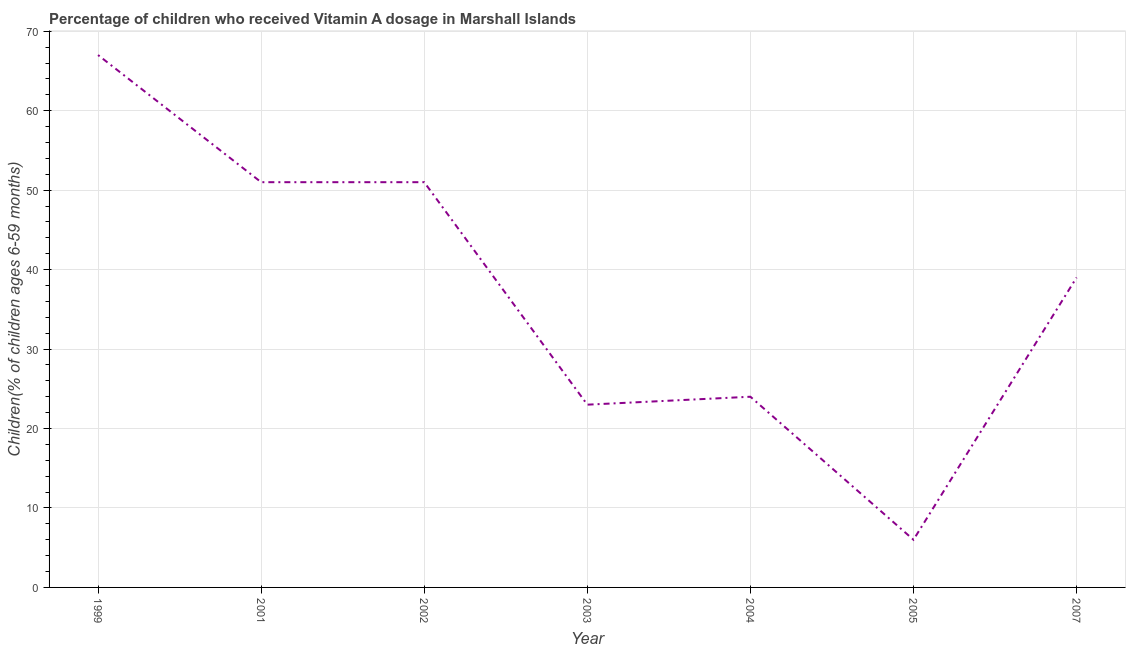What is the vitamin a supplementation coverage rate in 2005?
Give a very brief answer. 6. Across all years, what is the maximum vitamin a supplementation coverage rate?
Offer a terse response. 67. Across all years, what is the minimum vitamin a supplementation coverage rate?
Offer a terse response. 6. What is the sum of the vitamin a supplementation coverage rate?
Your response must be concise. 261. What is the difference between the vitamin a supplementation coverage rate in 1999 and 2002?
Offer a terse response. 16. What is the average vitamin a supplementation coverage rate per year?
Your answer should be compact. 37.29. What is the ratio of the vitamin a supplementation coverage rate in 2005 to that in 2007?
Your answer should be very brief. 0.15. What is the difference between the highest and the second highest vitamin a supplementation coverage rate?
Make the answer very short. 16. What is the difference between the highest and the lowest vitamin a supplementation coverage rate?
Your answer should be compact. 61. Does the vitamin a supplementation coverage rate monotonically increase over the years?
Your response must be concise. No. How many lines are there?
Give a very brief answer. 1. What is the difference between two consecutive major ticks on the Y-axis?
Ensure brevity in your answer.  10. Does the graph contain any zero values?
Your answer should be very brief. No. What is the title of the graph?
Offer a very short reply. Percentage of children who received Vitamin A dosage in Marshall Islands. What is the label or title of the Y-axis?
Your response must be concise. Children(% of children ages 6-59 months). What is the Children(% of children ages 6-59 months) in 1999?
Make the answer very short. 67. What is the Children(% of children ages 6-59 months) of 2004?
Make the answer very short. 24. What is the difference between the Children(% of children ages 6-59 months) in 1999 and 2002?
Make the answer very short. 16. What is the difference between the Children(% of children ages 6-59 months) in 1999 and 2007?
Make the answer very short. 28. What is the difference between the Children(% of children ages 6-59 months) in 2001 and 2003?
Keep it short and to the point. 28. What is the difference between the Children(% of children ages 6-59 months) in 2001 and 2007?
Keep it short and to the point. 12. What is the difference between the Children(% of children ages 6-59 months) in 2002 and 2004?
Provide a short and direct response. 27. What is the difference between the Children(% of children ages 6-59 months) in 2003 and 2004?
Your response must be concise. -1. What is the difference between the Children(% of children ages 6-59 months) in 2003 and 2005?
Your response must be concise. 17. What is the difference between the Children(% of children ages 6-59 months) in 2004 and 2005?
Offer a terse response. 18. What is the difference between the Children(% of children ages 6-59 months) in 2004 and 2007?
Keep it short and to the point. -15. What is the difference between the Children(% of children ages 6-59 months) in 2005 and 2007?
Ensure brevity in your answer.  -33. What is the ratio of the Children(% of children ages 6-59 months) in 1999 to that in 2001?
Give a very brief answer. 1.31. What is the ratio of the Children(% of children ages 6-59 months) in 1999 to that in 2002?
Provide a succinct answer. 1.31. What is the ratio of the Children(% of children ages 6-59 months) in 1999 to that in 2003?
Provide a succinct answer. 2.91. What is the ratio of the Children(% of children ages 6-59 months) in 1999 to that in 2004?
Provide a short and direct response. 2.79. What is the ratio of the Children(% of children ages 6-59 months) in 1999 to that in 2005?
Offer a terse response. 11.17. What is the ratio of the Children(% of children ages 6-59 months) in 1999 to that in 2007?
Keep it short and to the point. 1.72. What is the ratio of the Children(% of children ages 6-59 months) in 2001 to that in 2003?
Your response must be concise. 2.22. What is the ratio of the Children(% of children ages 6-59 months) in 2001 to that in 2004?
Keep it short and to the point. 2.12. What is the ratio of the Children(% of children ages 6-59 months) in 2001 to that in 2007?
Offer a very short reply. 1.31. What is the ratio of the Children(% of children ages 6-59 months) in 2002 to that in 2003?
Provide a succinct answer. 2.22. What is the ratio of the Children(% of children ages 6-59 months) in 2002 to that in 2004?
Offer a terse response. 2.12. What is the ratio of the Children(% of children ages 6-59 months) in 2002 to that in 2005?
Provide a succinct answer. 8.5. What is the ratio of the Children(% of children ages 6-59 months) in 2002 to that in 2007?
Your answer should be very brief. 1.31. What is the ratio of the Children(% of children ages 6-59 months) in 2003 to that in 2004?
Ensure brevity in your answer.  0.96. What is the ratio of the Children(% of children ages 6-59 months) in 2003 to that in 2005?
Your answer should be compact. 3.83. What is the ratio of the Children(% of children ages 6-59 months) in 2003 to that in 2007?
Your answer should be very brief. 0.59. What is the ratio of the Children(% of children ages 6-59 months) in 2004 to that in 2005?
Provide a succinct answer. 4. What is the ratio of the Children(% of children ages 6-59 months) in 2004 to that in 2007?
Keep it short and to the point. 0.61. What is the ratio of the Children(% of children ages 6-59 months) in 2005 to that in 2007?
Make the answer very short. 0.15. 